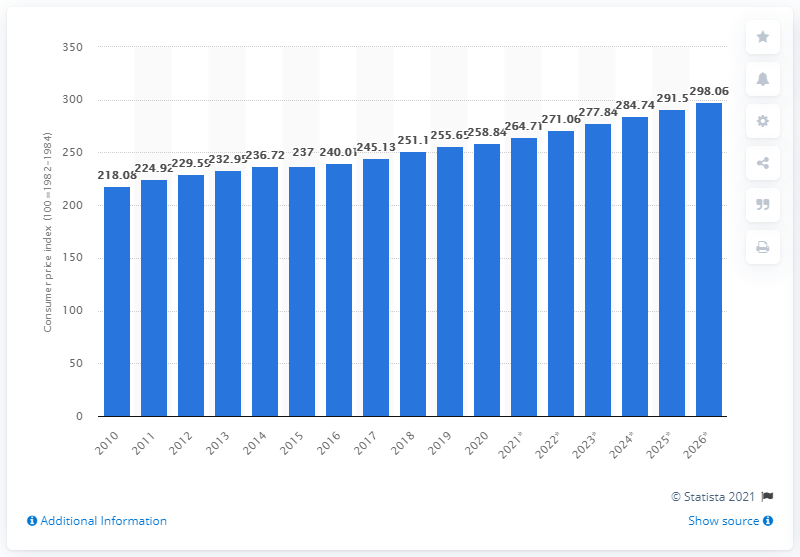Specify some key components in this picture. The Consumer Price Index is projected to be at 264.71 in 2021. 